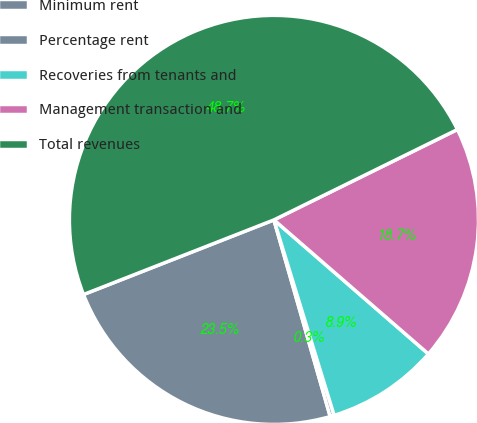Convert chart to OTSL. <chart><loc_0><loc_0><loc_500><loc_500><pie_chart><fcel>Minimum rent<fcel>Percentage rent<fcel>Recoveries from tenants and<fcel>Management transaction and<fcel>Total revenues<nl><fcel>23.49%<fcel>0.32%<fcel>8.87%<fcel>18.66%<fcel>48.66%<nl></chart> 